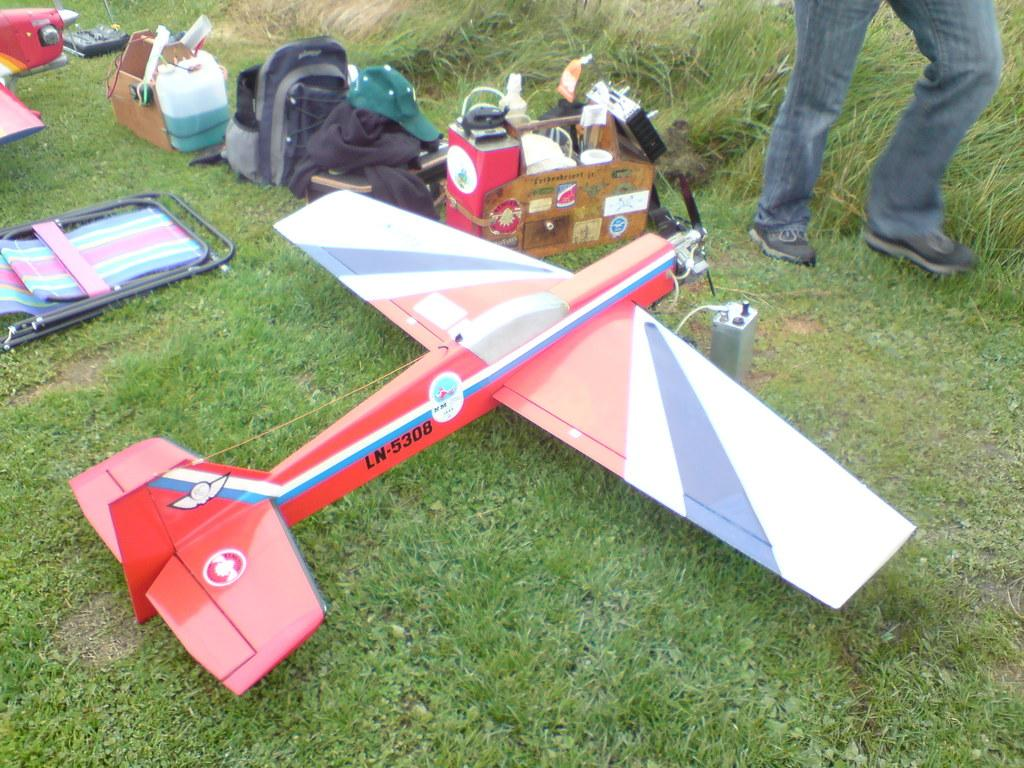<image>
Create a compact narrative representing the image presented. Red model plane with a plate which says "LN5308". 